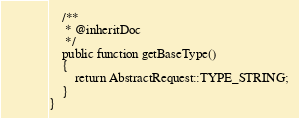<code> <loc_0><loc_0><loc_500><loc_500><_PHP_>
    /**
     * @inheritDoc
     */
    public function getBaseType()
    {
        return AbstractRequest::TYPE_STRING;
    }
}
</code> 